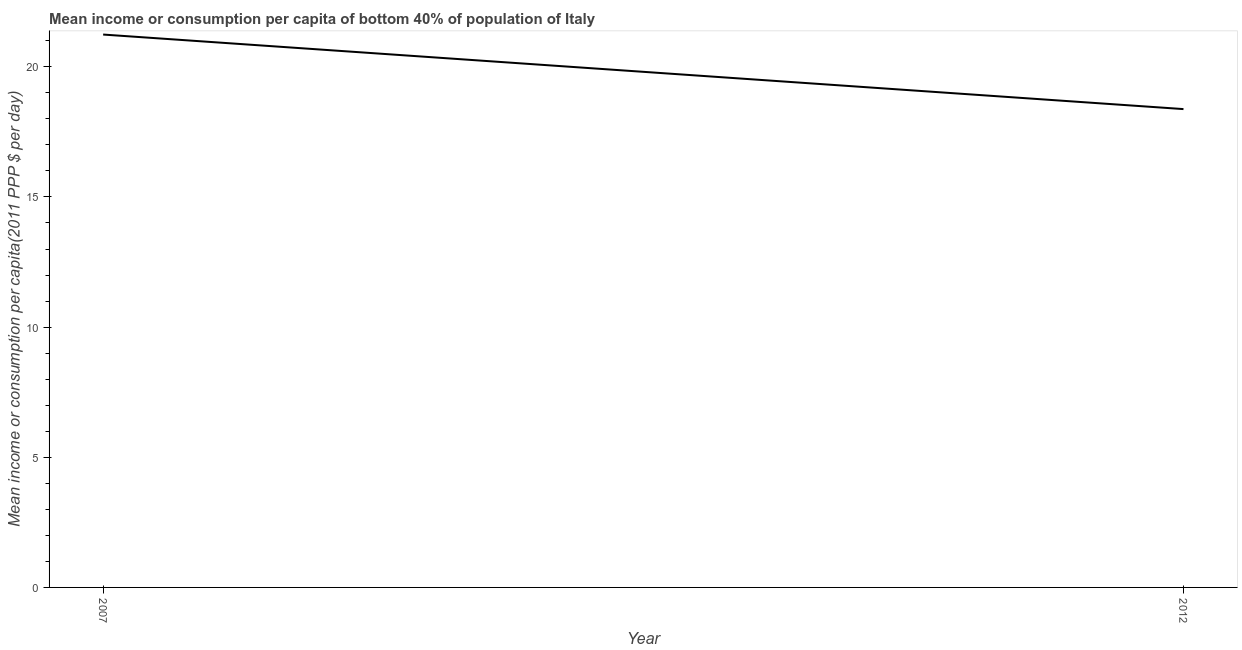What is the mean income or consumption in 2007?
Keep it short and to the point. 21.24. Across all years, what is the maximum mean income or consumption?
Your answer should be compact. 21.24. Across all years, what is the minimum mean income or consumption?
Offer a terse response. 18.37. In which year was the mean income or consumption maximum?
Keep it short and to the point. 2007. What is the sum of the mean income or consumption?
Your answer should be very brief. 39.61. What is the difference between the mean income or consumption in 2007 and 2012?
Offer a terse response. 2.86. What is the average mean income or consumption per year?
Offer a very short reply. 19.81. What is the median mean income or consumption?
Ensure brevity in your answer.  19.81. In how many years, is the mean income or consumption greater than 12 $?
Your answer should be compact. 2. What is the ratio of the mean income or consumption in 2007 to that in 2012?
Offer a very short reply. 1.16. In how many years, is the mean income or consumption greater than the average mean income or consumption taken over all years?
Provide a short and direct response. 1. Does the mean income or consumption monotonically increase over the years?
Your response must be concise. No. How many years are there in the graph?
Give a very brief answer. 2. What is the difference between two consecutive major ticks on the Y-axis?
Provide a short and direct response. 5. Does the graph contain any zero values?
Provide a short and direct response. No. Does the graph contain grids?
Your response must be concise. No. What is the title of the graph?
Keep it short and to the point. Mean income or consumption per capita of bottom 40% of population of Italy. What is the label or title of the Y-axis?
Provide a short and direct response. Mean income or consumption per capita(2011 PPP $ per day). What is the Mean income or consumption per capita(2011 PPP $ per day) in 2007?
Provide a short and direct response. 21.24. What is the Mean income or consumption per capita(2011 PPP $ per day) in 2012?
Make the answer very short. 18.37. What is the difference between the Mean income or consumption per capita(2011 PPP $ per day) in 2007 and 2012?
Your answer should be very brief. 2.86. What is the ratio of the Mean income or consumption per capita(2011 PPP $ per day) in 2007 to that in 2012?
Your response must be concise. 1.16. 